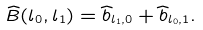<formula> <loc_0><loc_0><loc_500><loc_500>\widehat { B } ( l _ { 0 } , l _ { 1 } ) = \widehat { b } _ { l _ { 1 } , 0 } + \widehat { b } _ { l _ { 0 } , 1 } .</formula> 